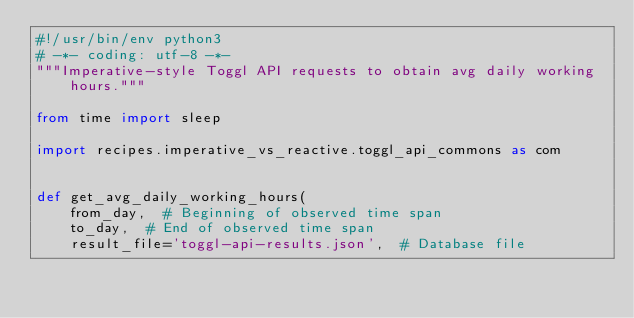<code> <loc_0><loc_0><loc_500><loc_500><_Python_>#!/usr/bin/env python3
# -*- coding: utf-8 -*-
"""Imperative-style Toggl API requests to obtain avg daily working hours."""

from time import sleep

import recipes.imperative_vs_reactive.toggl_api_commons as com


def get_avg_daily_working_hours(
    from_day,  # Beginning of observed time span
    to_day,  # End of observed time span
    result_file='toggl-api-results.json',  # Database file</code> 